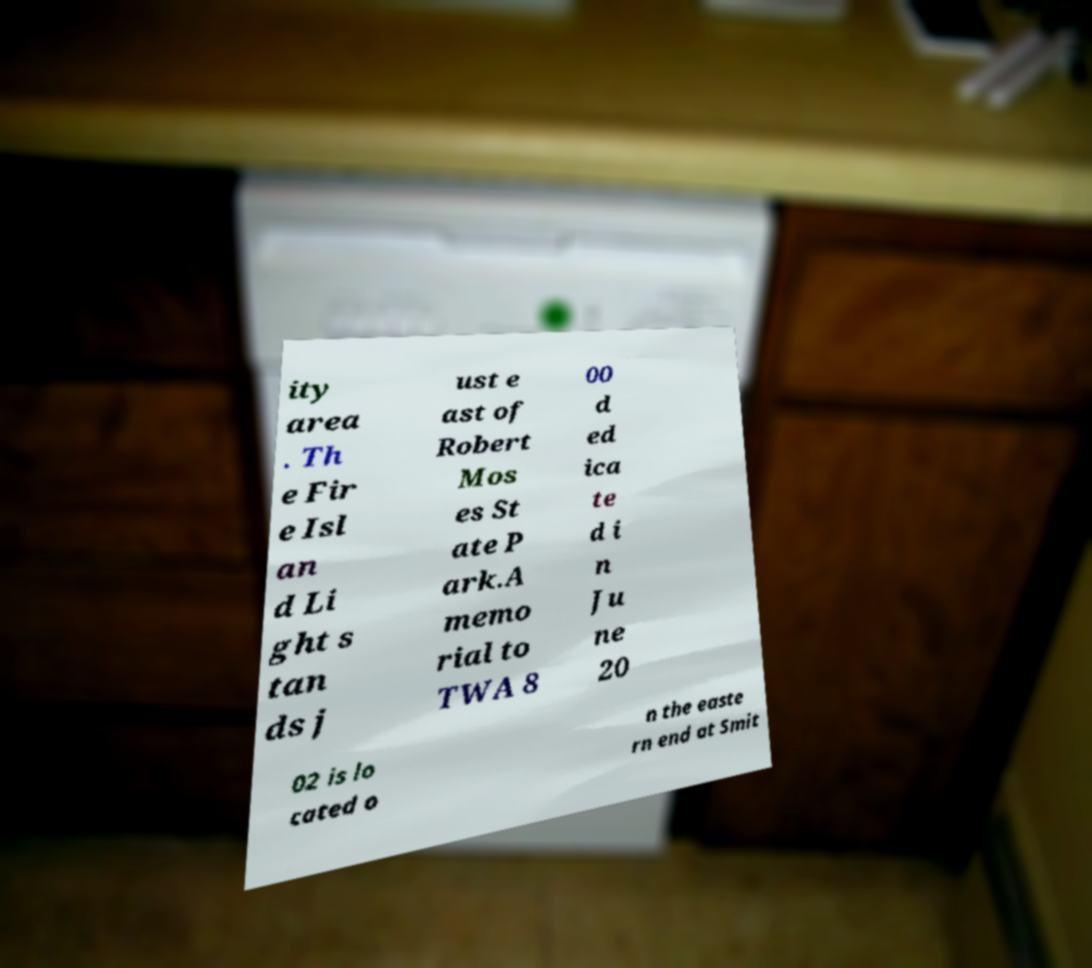For documentation purposes, I need the text within this image transcribed. Could you provide that? ity area . Th e Fir e Isl an d Li ght s tan ds j ust e ast of Robert Mos es St ate P ark.A memo rial to TWA 8 00 d ed ica te d i n Ju ne 20 02 is lo cated o n the easte rn end at Smit 